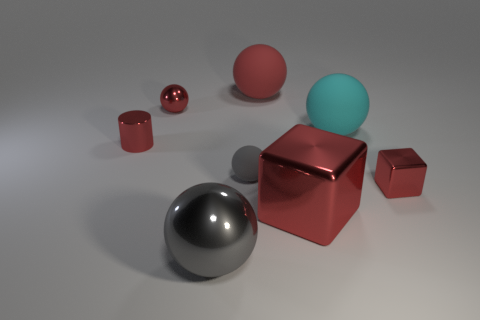Subtract all small matte balls. How many balls are left? 4 Subtract all cyan balls. How many balls are left? 4 Subtract all brown spheres. Subtract all gray cylinders. How many spheres are left? 5 Add 2 big red metallic objects. How many objects exist? 10 Subtract all cubes. How many objects are left? 6 Subtract 0 purple blocks. How many objects are left? 8 Subtract all big cyan metallic cylinders. Subtract all shiny things. How many objects are left? 3 Add 6 red metallic blocks. How many red metallic blocks are left? 8 Add 6 big red spheres. How many big red spheres exist? 7 